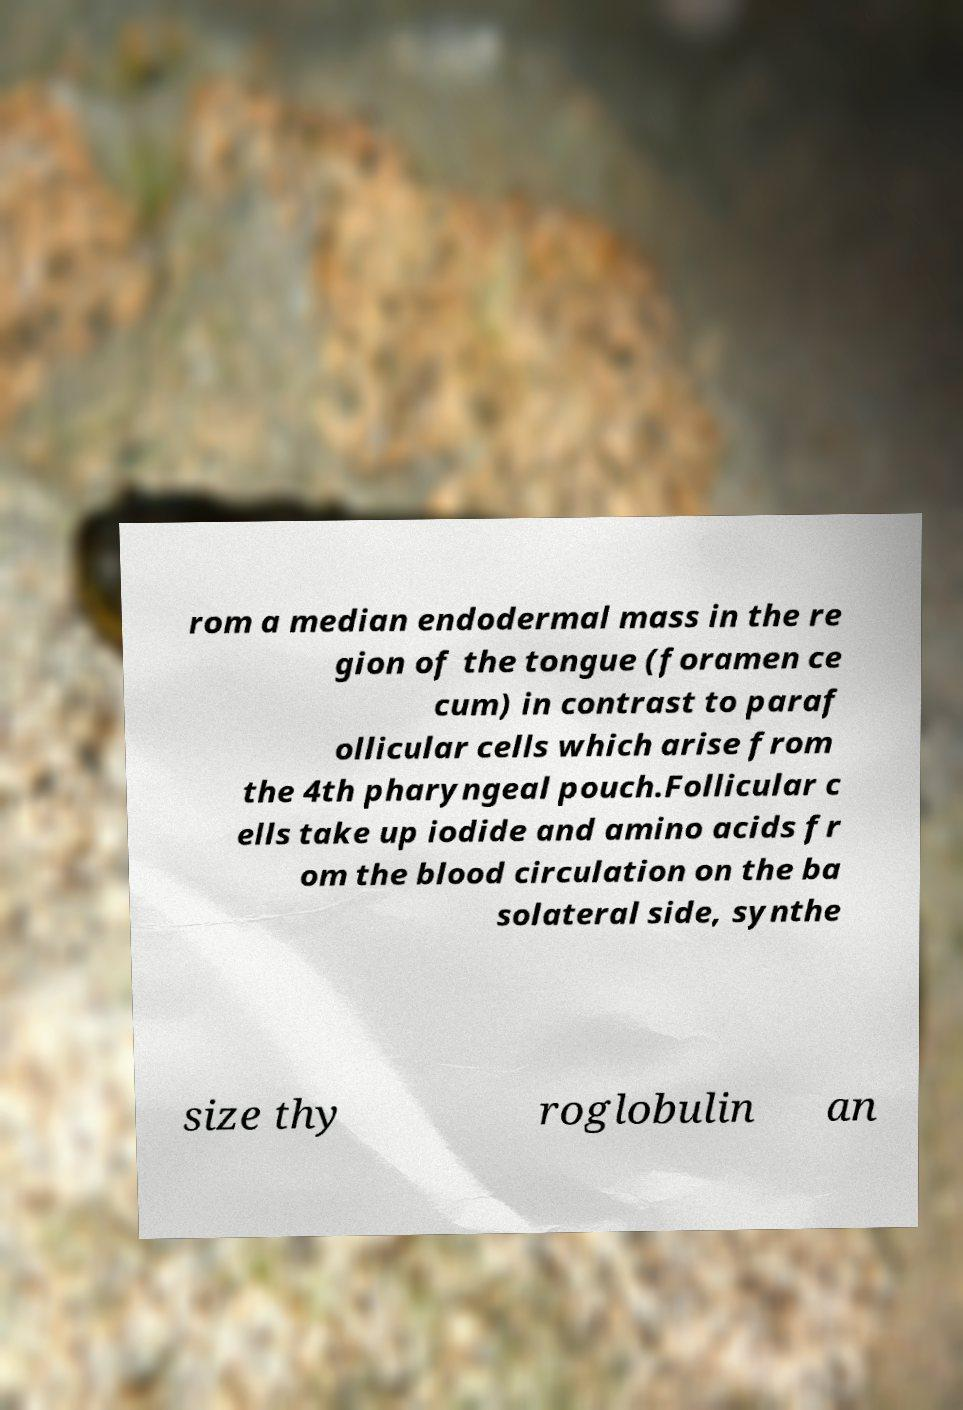Could you extract and type out the text from this image? rom a median endodermal mass in the re gion of the tongue (foramen ce cum) in contrast to paraf ollicular cells which arise from the 4th pharyngeal pouch.Follicular c ells take up iodide and amino acids fr om the blood circulation on the ba solateral side, synthe size thy roglobulin an 